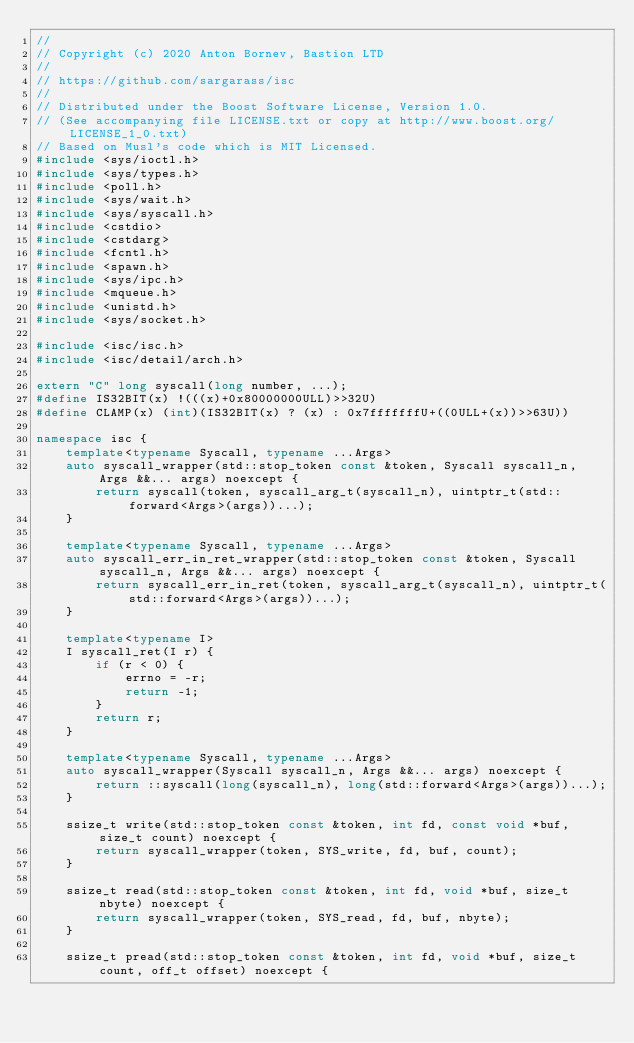<code> <loc_0><loc_0><loc_500><loc_500><_C++_>//
// Copyright (c) 2020 Anton Bornev, Bastion LTD
//
// https://github.com/sargarass/isc
//
// Distributed under the Boost Software License, Version 1.0.
// (See accompanying file LICENSE.txt or copy at http://www.boost.org/LICENSE_1_0.txt)
// Based on Musl's code which is MIT Licensed.
#include <sys/ioctl.h>
#include <sys/types.h>
#include <poll.h>
#include <sys/wait.h>
#include <sys/syscall.h>
#include <cstdio>
#include <cstdarg>
#include <fcntl.h>
#include <spawn.h>
#include <sys/ipc.h>
#include <mqueue.h>
#include <unistd.h>
#include <sys/socket.h>

#include <isc/isc.h>
#include <isc/detail/arch.h>

extern "C" long syscall(long number, ...);
#define IS32BIT(x) !(((x)+0x80000000ULL)>>32U)
#define CLAMP(x) (int)(IS32BIT(x) ? (x) : 0x7fffffffU+((0ULL+(x))>>63U))

namespace isc {
    template<typename Syscall, typename ...Args>
    auto syscall_wrapper(std::stop_token const &token, Syscall syscall_n, Args &&... args) noexcept {
        return syscall(token, syscall_arg_t(syscall_n), uintptr_t(std::forward<Args>(args))...);
    }

    template<typename Syscall, typename ...Args>
    auto syscall_err_in_ret_wrapper(std::stop_token const &token, Syscall syscall_n, Args &&... args) noexcept {
        return syscall_err_in_ret(token, syscall_arg_t(syscall_n), uintptr_t(std::forward<Args>(args))...);
    }

    template<typename I>
    I syscall_ret(I r) {
        if (r < 0) {
            errno = -r;
            return -1;
        }
        return r;
    }

    template<typename Syscall, typename ...Args>
    auto syscall_wrapper(Syscall syscall_n, Args &&... args) noexcept {
        return ::syscall(long(syscall_n), long(std::forward<Args>(args))...);
    }

    ssize_t write(std::stop_token const &token, int fd, const void *buf, size_t count) noexcept {
        return syscall_wrapper(token, SYS_write, fd, buf, count);
    }
    
    ssize_t read(std::stop_token const &token, int fd, void *buf, size_t nbyte) noexcept {
        return syscall_wrapper(token, SYS_read, fd, buf, nbyte);
    }

    ssize_t pread(std::stop_token const &token, int fd, void *buf, size_t count, off_t offset) noexcept {</code> 